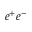<formula> <loc_0><loc_0><loc_500><loc_500>e ^ { + } e ^ { - }</formula> 